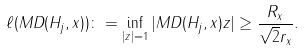<formula> <loc_0><loc_0><loc_500><loc_500>\ell ( M D ( H _ { j } , x ) ) \colon = \inf _ { | z | = 1 } | M D ( H _ { j } , x ) z | \geq \frac { R _ { x } } { \sqrt { 2 } r _ { x } } .</formula> 